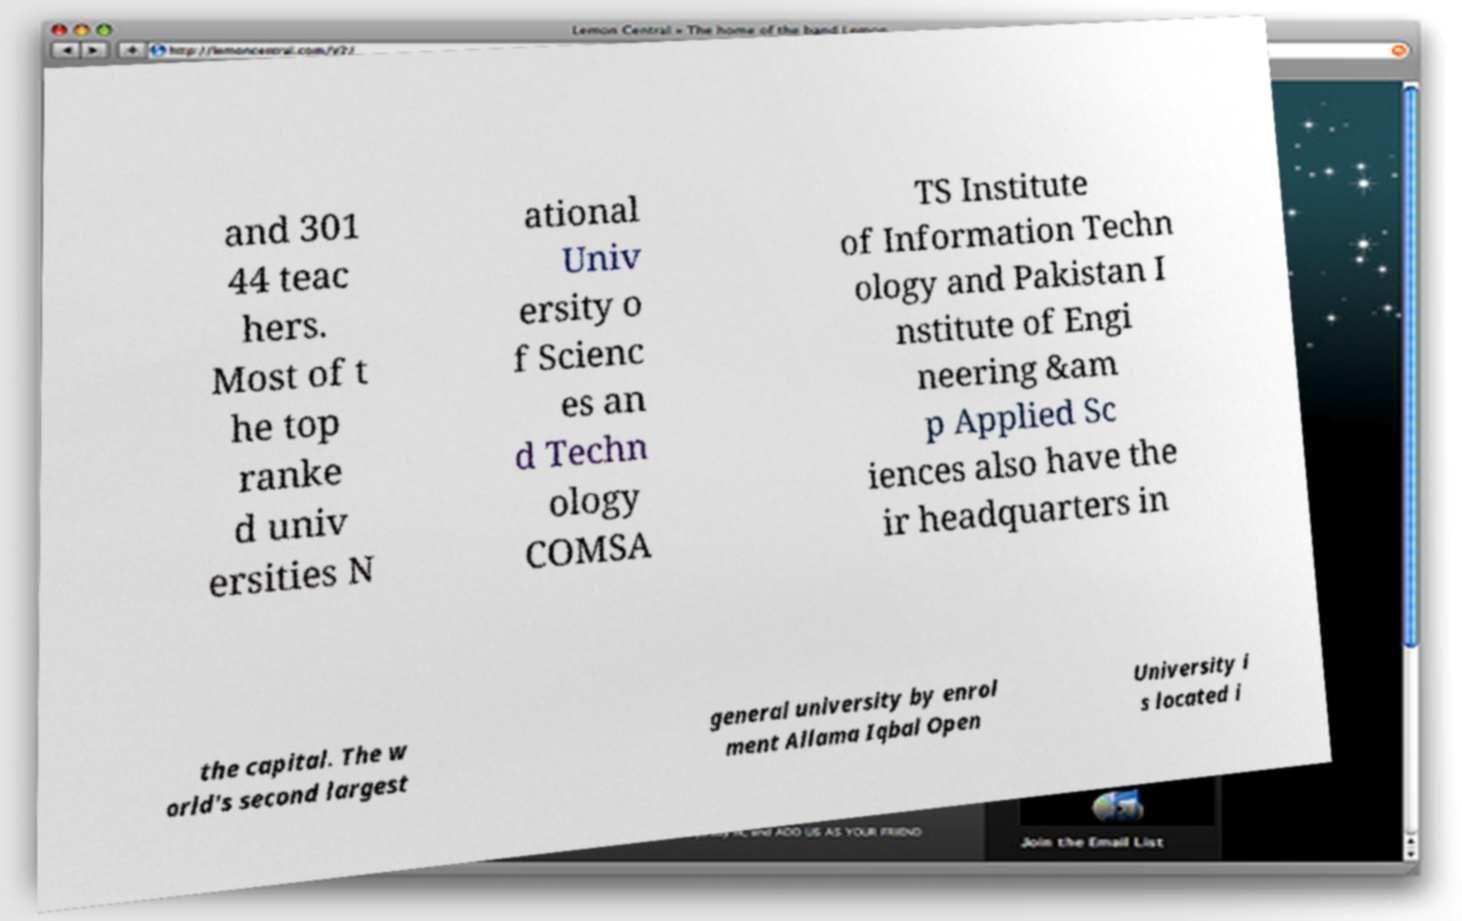What messages or text are displayed in this image? I need them in a readable, typed format. and 301 44 teac hers. Most of t he top ranke d univ ersities N ational Univ ersity o f Scienc es an d Techn ology COMSA TS Institute of Information Techn ology and Pakistan I nstitute of Engi neering &am p Applied Sc iences also have the ir headquarters in the capital. The w orld's second largest general university by enrol ment Allama Iqbal Open University i s located i 